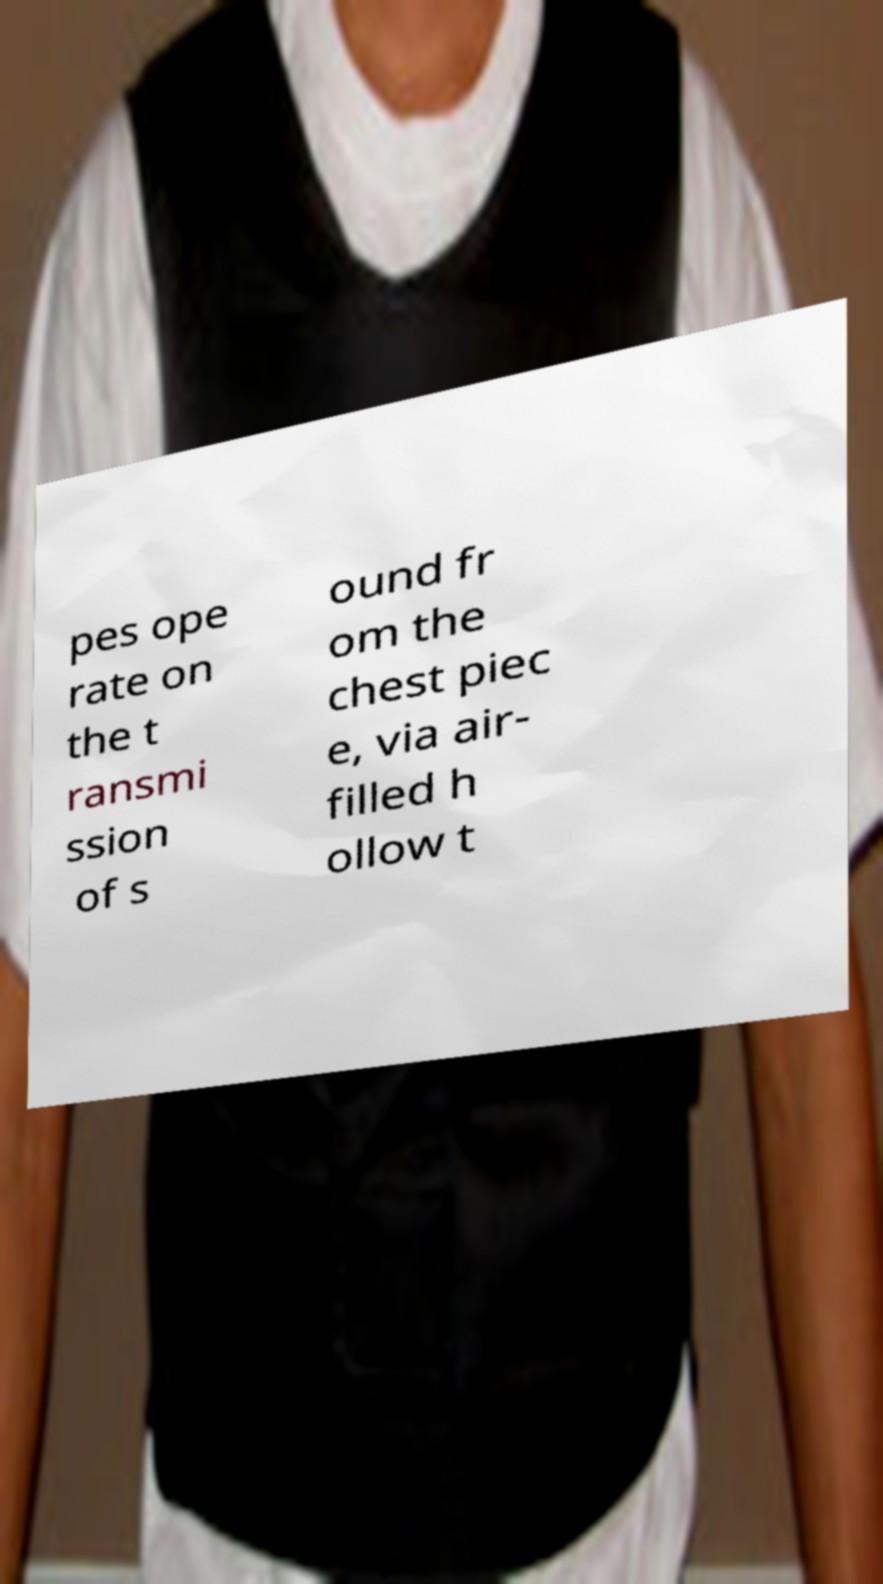Can you read and provide the text displayed in the image?This photo seems to have some interesting text. Can you extract and type it out for me? pes ope rate on the t ransmi ssion of s ound fr om the chest piec e, via air- filled h ollow t 